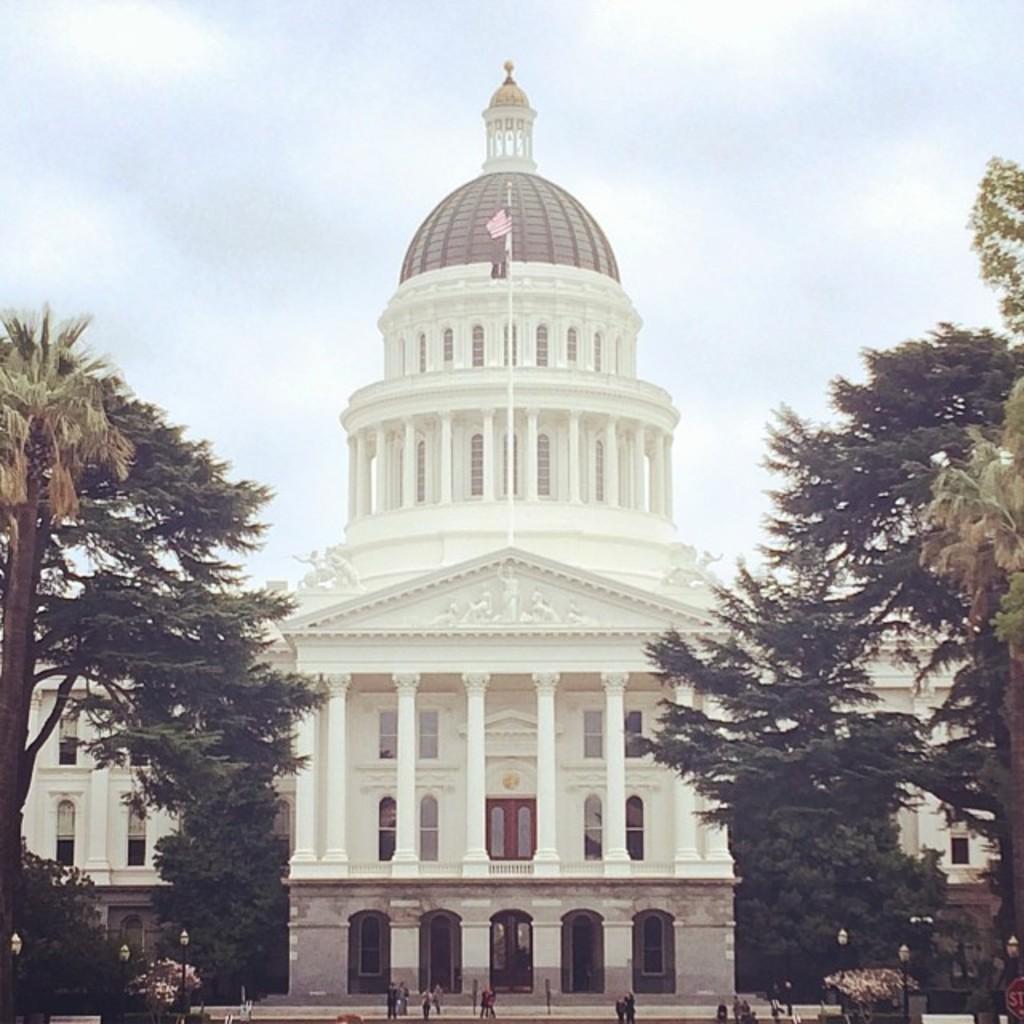How would you summarize this image in a sentence or two? In this image we can see a few people are walking, we can see light poles, trees, white building and the sky in the background. 